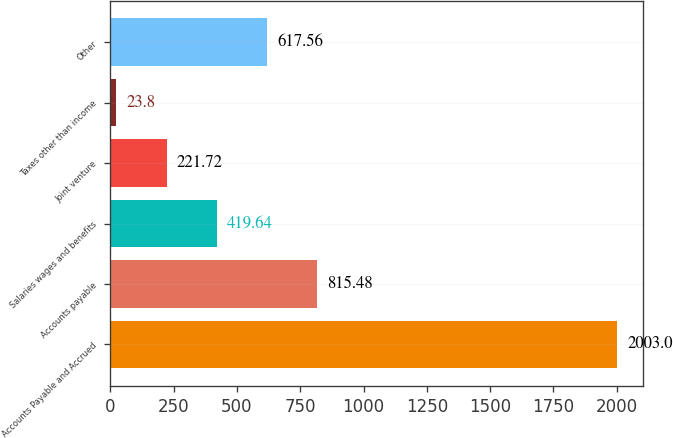Convert chart. <chart><loc_0><loc_0><loc_500><loc_500><bar_chart><fcel>Accounts Payable and Accrued<fcel>Accounts payable<fcel>Salaries wages and benefits<fcel>Joint venture<fcel>Taxes other than income<fcel>Other<nl><fcel>2003<fcel>815.48<fcel>419.64<fcel>221.72<fcel>23.8<fcel>617.56<nl></chart> 